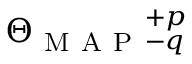<formula> <loc_0><loc_0><loc_500><loc_500>\Theta _ { M A P _ { - q } ^ { + p }</formula> 